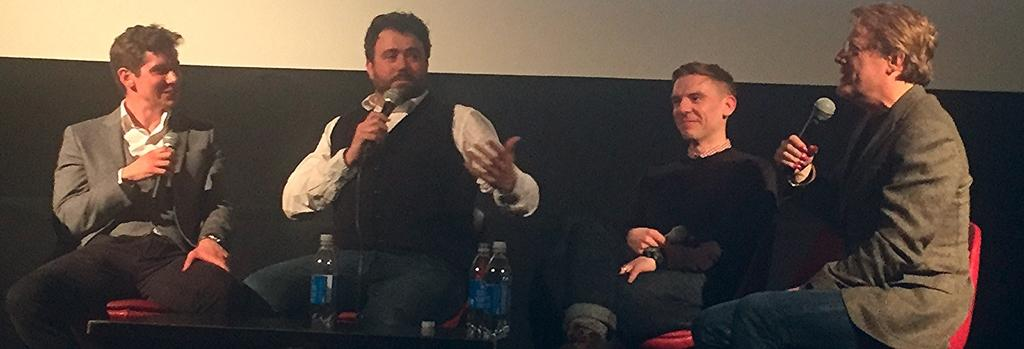How many people are in the image? There is a group of persons in the image. What are the persons doing in the image? The persons are sitting on chairs and holding microphones. What objects are in front of the persons? There are bottles in front of the persons. What type of orange can be seen in the image? There is no orange present in the image. How many deer are visible in the image? There are no deer present in the image. 